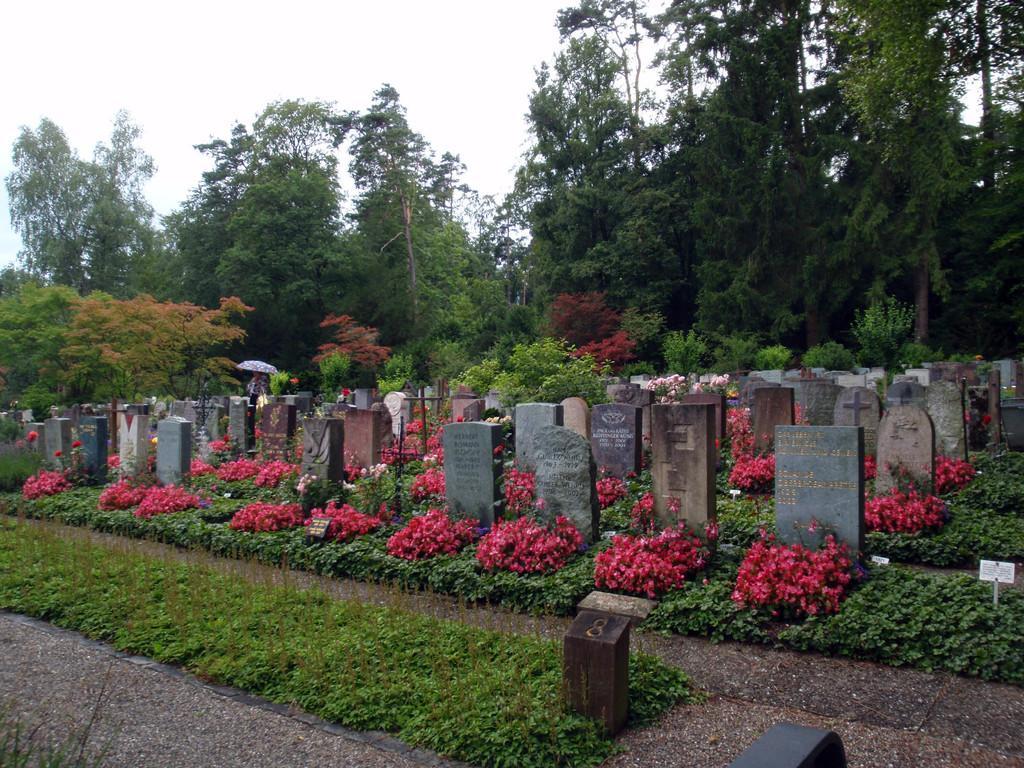Could you give a brief overview of what you see in this image? In this picture I can see a place where we have some cemeteries and also we can see some flowers, around we can see some trees and plants. 